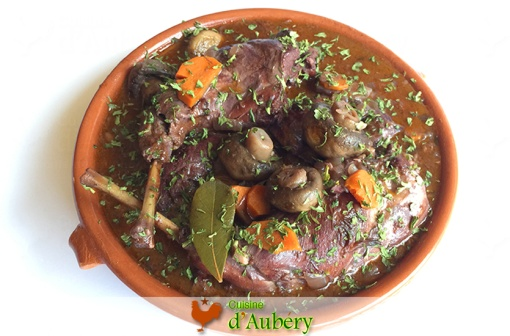What is the backstory of this Coq au Vin's presentation style? This presentation style of **Coq au Vin** is a nod to the rustic, home-style approach that embodies the essence of French country cooking. In the days of old, French villagers would gather around a communal table, sharing hearty meals cooked in terracotta dishes that retained heat, ensuring the food stayed warm throughout the dinner. The dish's rich and hearty presentation today maintains this tradition, aiming to evoke a sense of homeliness and comfort. The use of whole, visible ingredients like mushrooms, carrots, and herbs pays homage to the freshness and simplicity of the countryside's produce, while the bay leaf perched on top serves as a traditional finishing touch, symbolizing the chef's respect for time-honored culinary practices. Get wild and creative! If this dish had a secret ingredient with magical properties, what would it be, and what powers would it bestow upon those who eat it? In a fantastical twist, this **Coq au Vin** was prepared with a rare, enchanted truffle found deep within the mystical forests of Normandy. This truffle, when infused into the dish, bestows the power of elation and tranquility upon those who partake in it. As diners enjoy the rich, savory bites, they find themselves enveloped in a serene aura of joy and peace. Their senses heighten, allowing them to taste every subtle nuance with breathtaking clarity. Moreover, the enchanted truffle subtly sparkles within the sauce, visible only to those with pure intentions, adding an element of ethereal beauty to this already beautiful dish. 